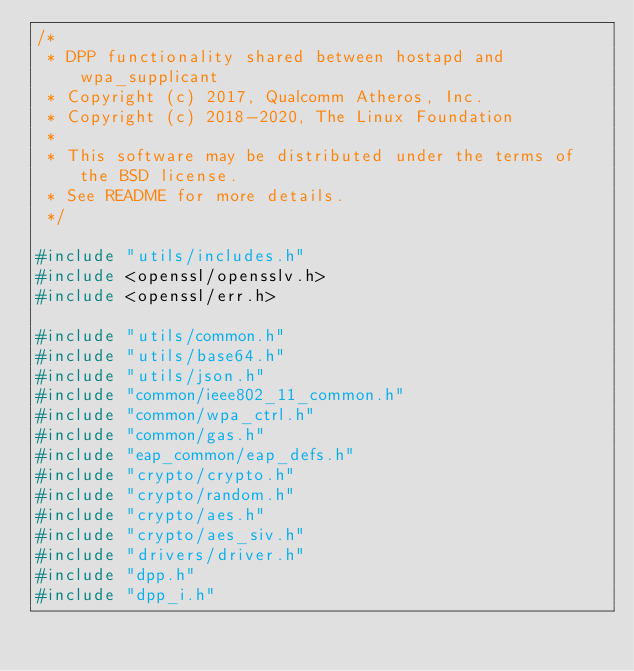<code> <loc_0><loc_0><loc_500><loc_500><_C_>/*
 * DPP functionality shared between hostapd and wpa_supplicant
 * Copyright (c) 2017, Qualcomm Atheros, Inc.
 * Copyright (c) 2018-2020, The Linux Foundation
 *
 * This software may be distributed under the terms of the BSD license.
 * See README for more details.
 */

#include "utils/includes.h"
#include <openssl/opensslv.h>
#include <openssl/err.h>

#include "utils/common.h"
#include "utils/base64.h"
#include "utils/json.h"
#include "common/ieee802_11_common.h"
#include "common/wpa_ctrl.h"
#include "common/gas.h"
#include "eap_common/eap_defs.h"
#include "crypto/crypto.h"
#include "crypto/random.h"
#include "crypto/aes.h"
#include "crypto/aes_siv.h"
#include "drivers/driver.h"
#include "dpp.h"
#include "dpp_i.h"

</code> 